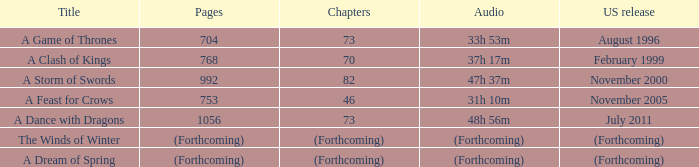In the united states, which publication has a total of 704 pages? August 1996. 